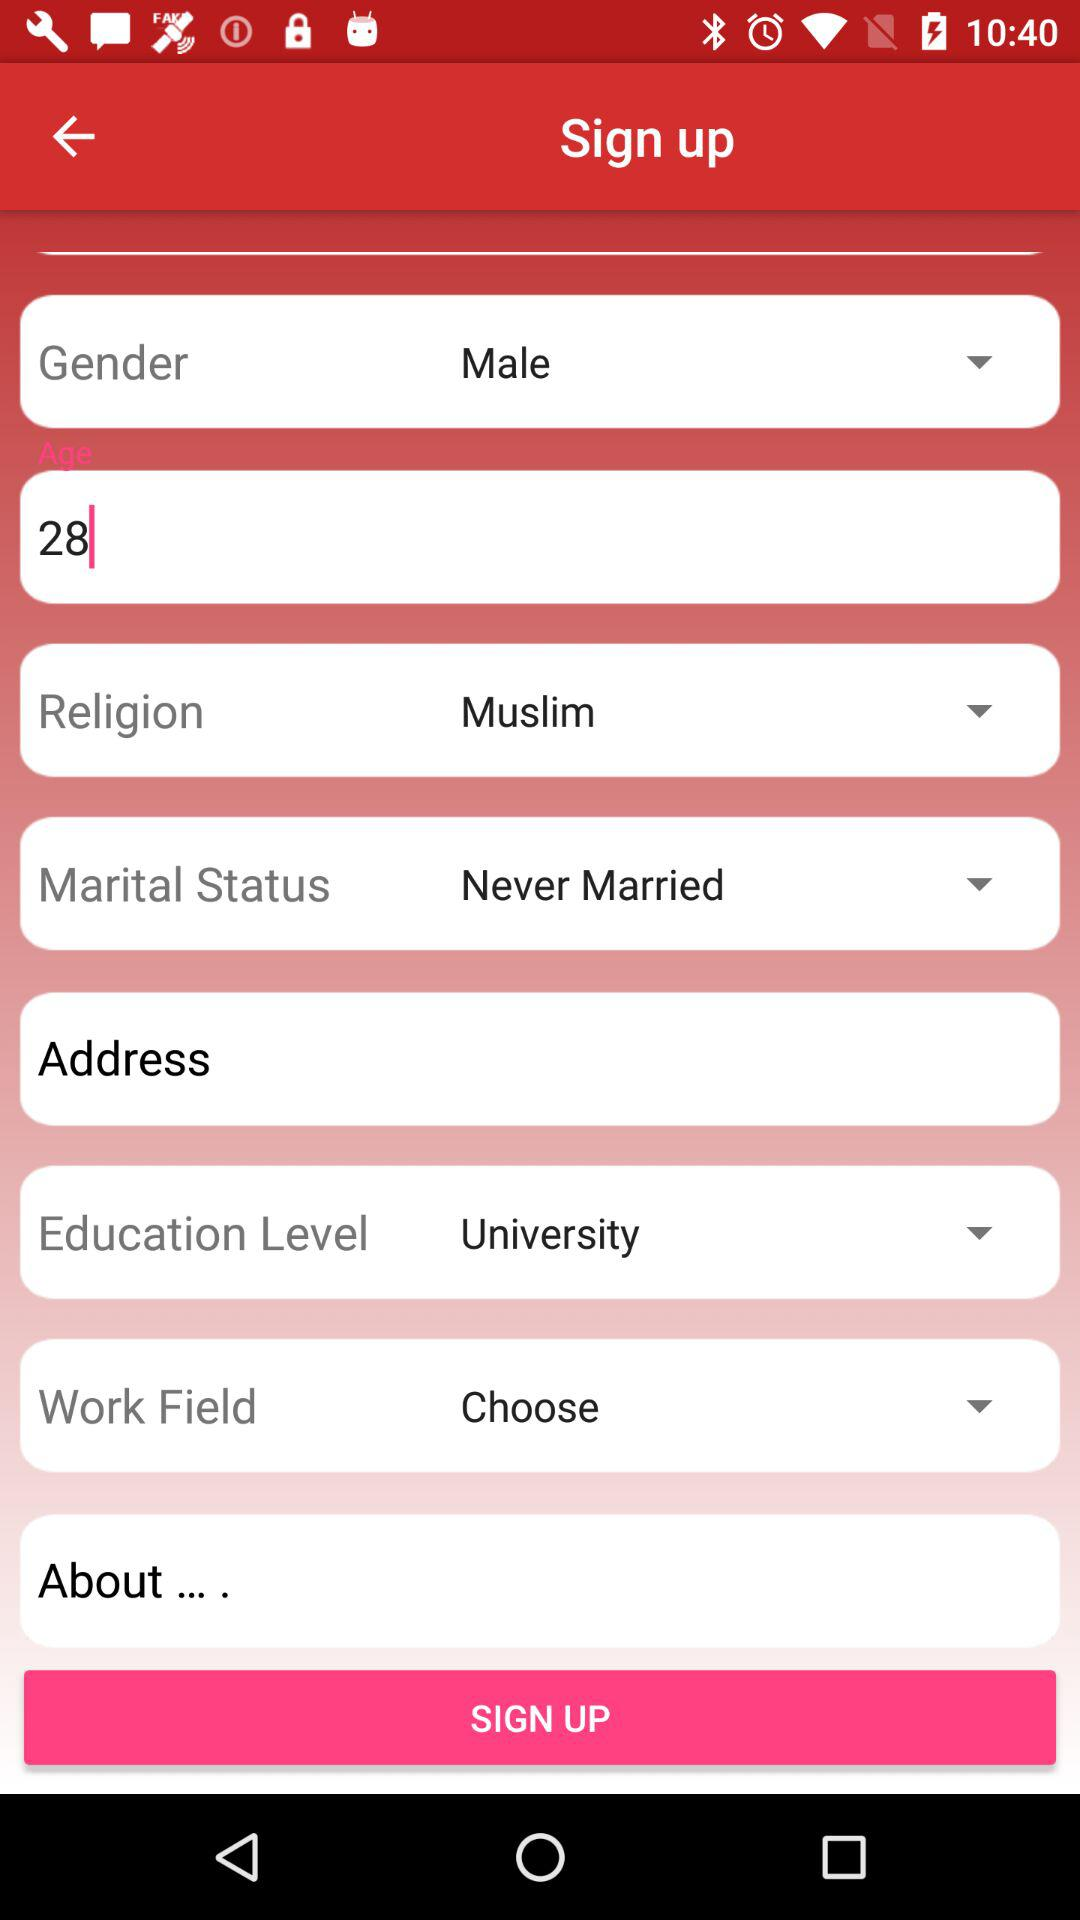What is the religion of the user? The user is Muslim. 